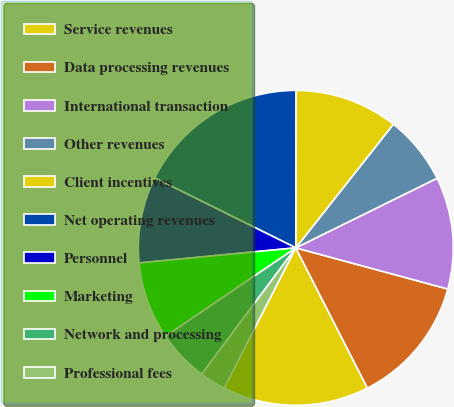<chart> <loc_0><loc_0><loc_500><loc_500><pie_chart><fcel>Service revenues<fcel>Data processing revenues<fcel>International transaction<fcel>Other revenues<fcel>Client incentives<fcel>Net operating revenues<fcel>Personnel<fcel>Marketing<fcel>Network and processing<fcel>Professional fees<nl><fcel>15.04%<fcel>13.27%<fcel>11.5%<fcel>7.08%<fcel>10.62%<fcel>17.69%<fcel>8.85%<fcel>7.97%<fcel>5.31%<fcel>2.66%<nl></chart> 